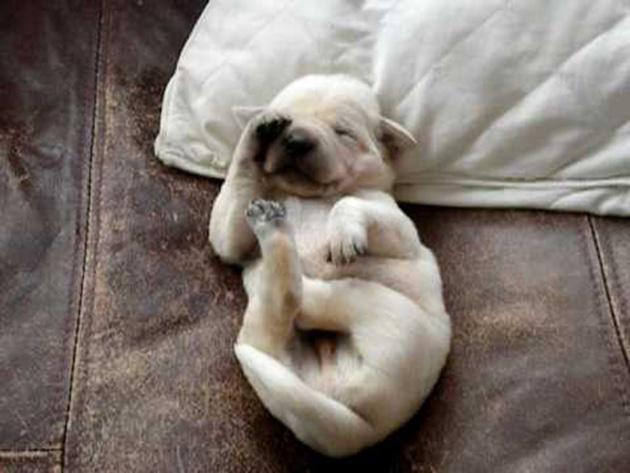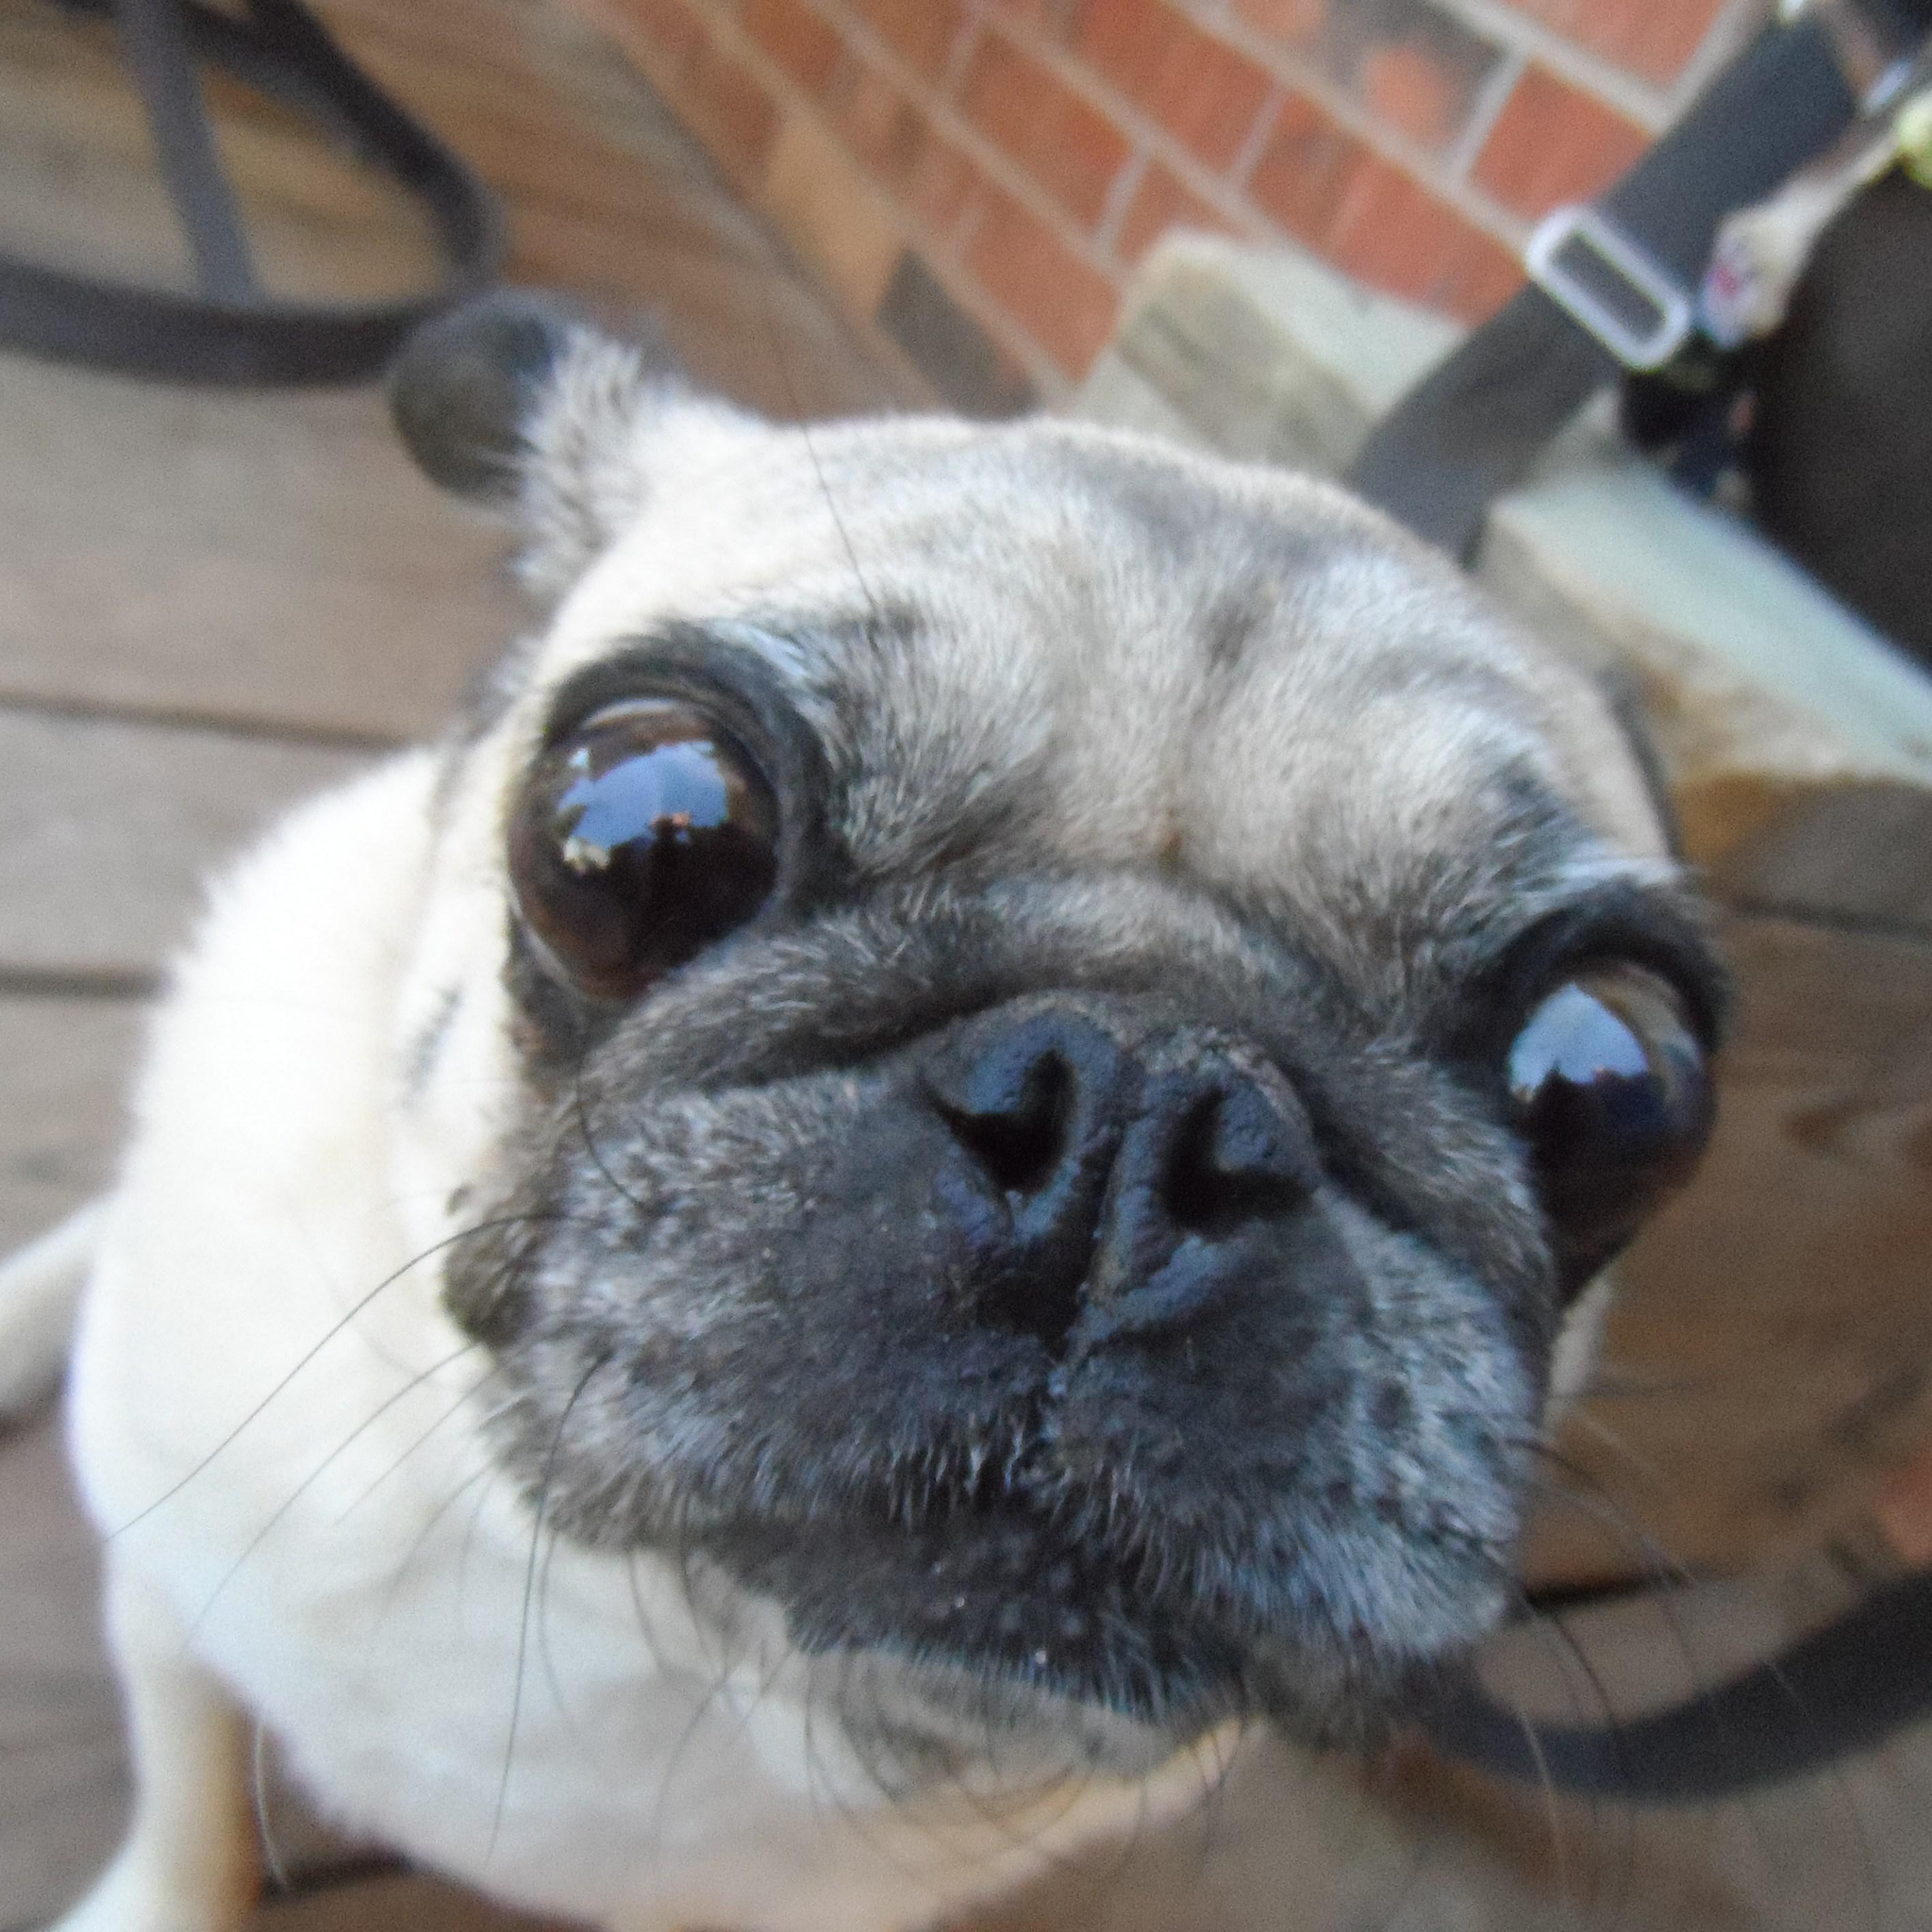The first image is the image on the left, the second image is the image on the right. Examine the images to the left and right. Is the description "An image shows two beige pug pups and a white spotted pug pup sleeping on top of a sleeping human baby." accurate? Answer yes or no. No. The first image is the image on the left, the second image is the image on the right. For the images displayed, is the sentence "The dogs in one of the images are sleeping on a baby." factually correct? Answer yes or no. No. 